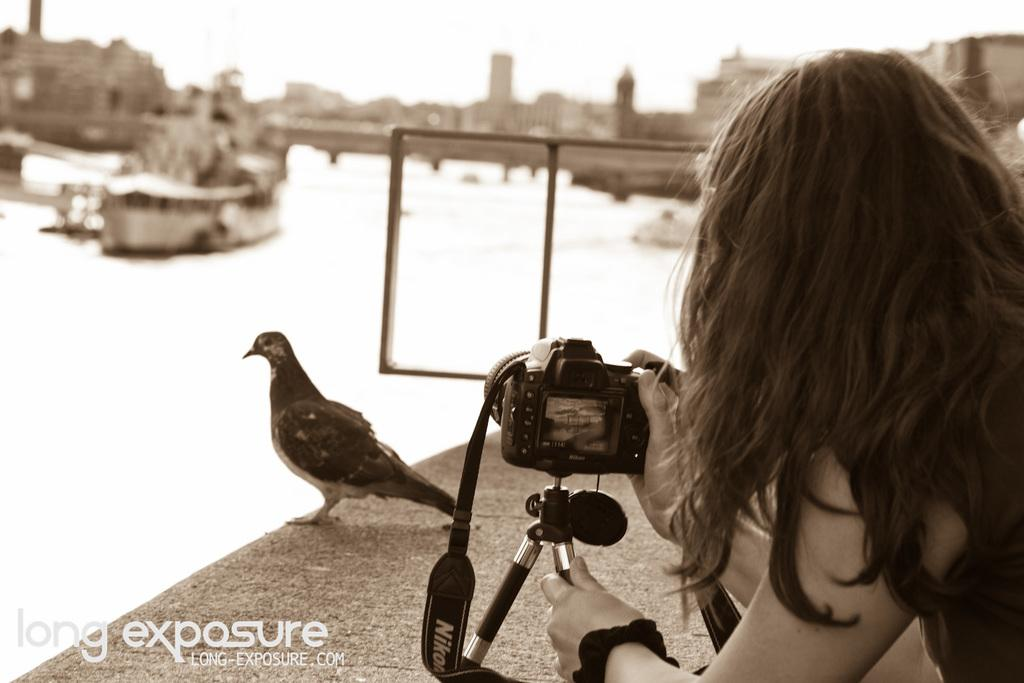What is the person in the image holding? The person in the image is holding a camera. What type of animal can be seen in the image? There is a bird in the image. What natural element is visible in the image? Water is visible in the image. What can be seen in the distance in the image? There are buildings in the background of the image. Can you see any feathers on the bird in the image? There is no mention of feathers on the bird in the provided facts, so we cannot determine if feathers are visible in the image. Is there any evidence of slavery in the image? There is no mention of slavery or any related elements in the provided facts, so we cannot determine if slavery is present in the image. 